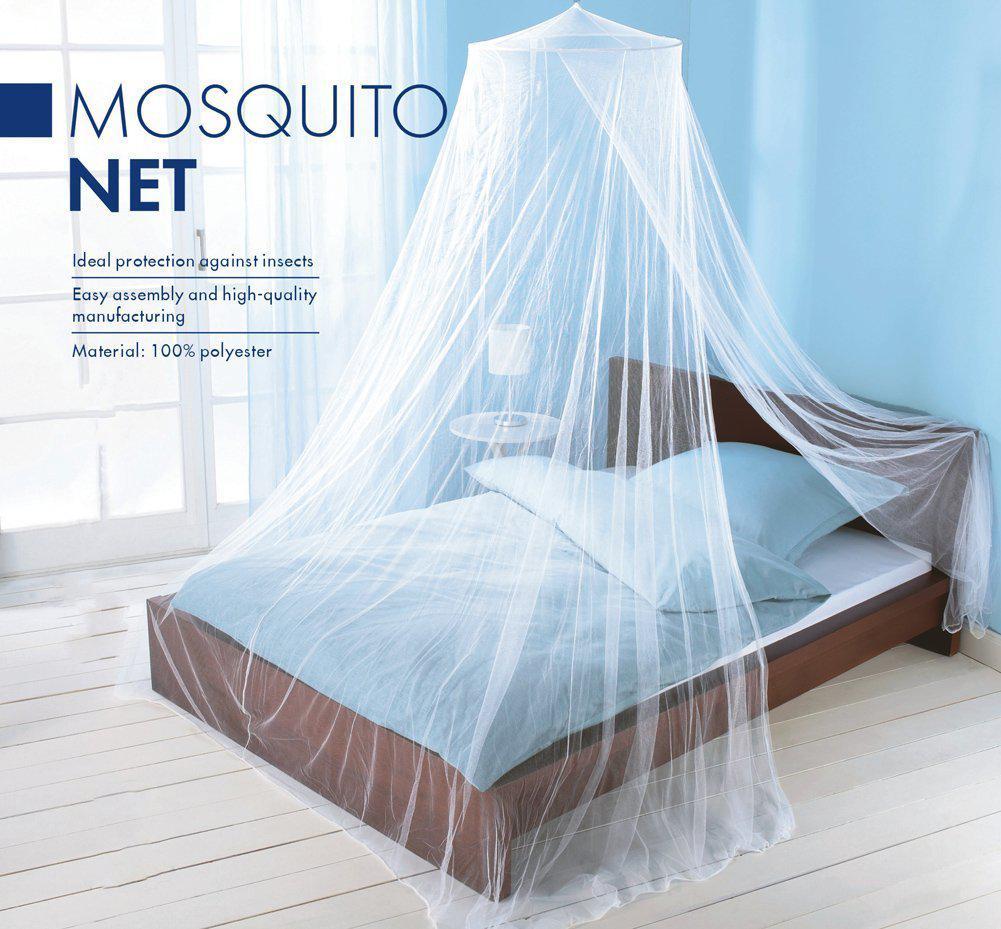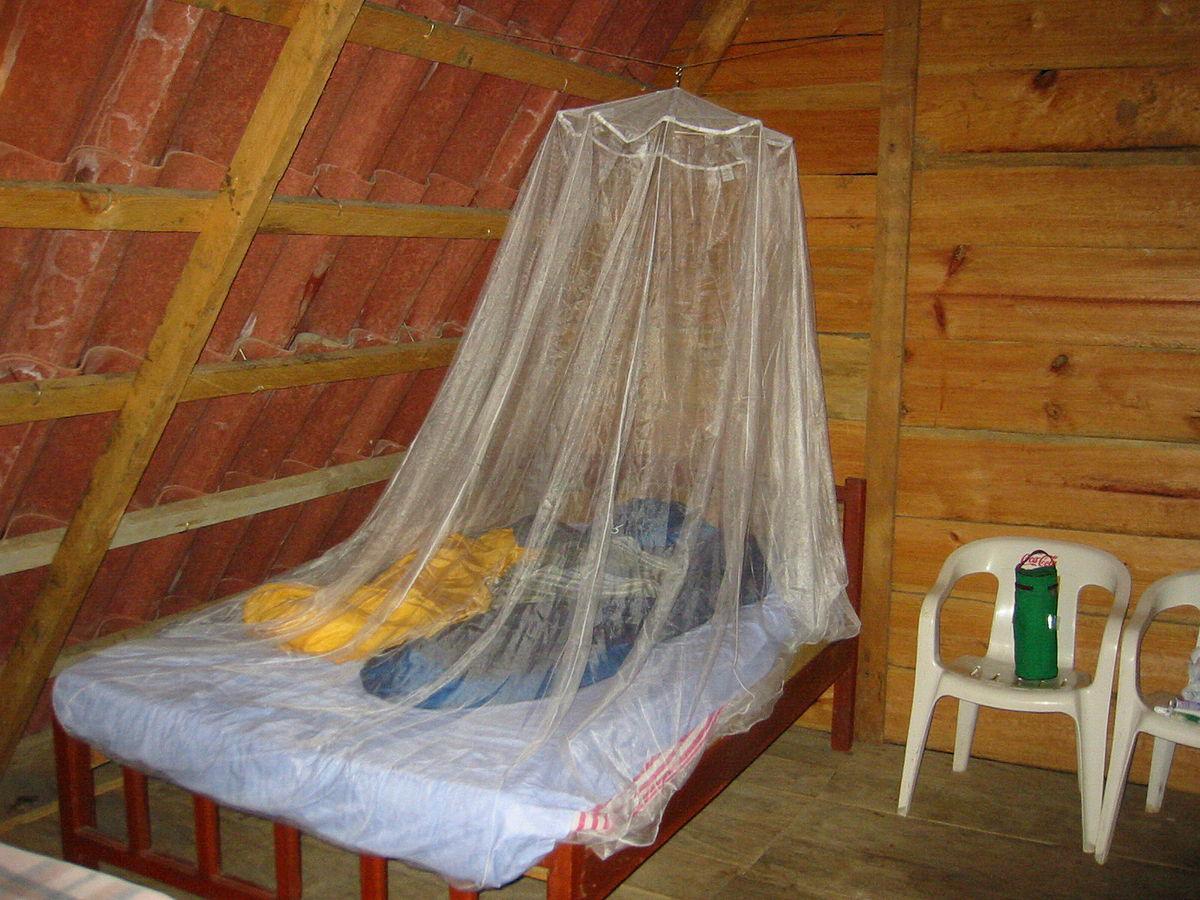The first image is the image on the left, the second image is the image on the right. For the images shown, is this caption "Two mattresses are completely covered by draped mosquito netting." true? Answer yes or no. No. 